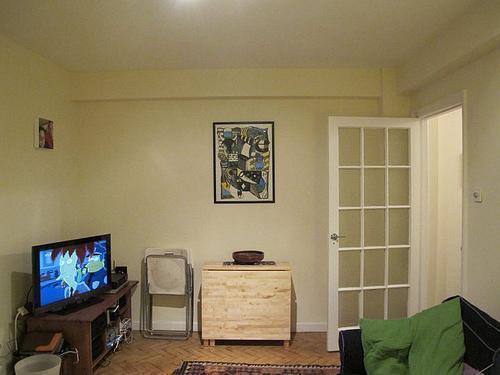How many doors are there?
Give a very brief answer. 1. 